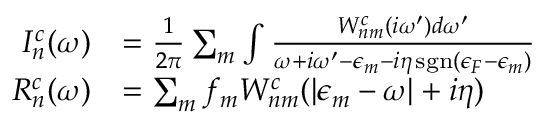<formula> <loc_0><loc_0><loc_500><loc_500>\begin{array} { r l } { I _ { n } ^ { c } ( \omega ) } & { = \frac { 1 } { 2 \pi } \sum _ { m } \int \frac { W _ { n m } ^ { c } ( i \omega ^ { \prime } ) d \omega ^ { \prime } } { \omega + i \omega ^ { \prime } - \epsilon _ { m } - i \eta \, s g n ( \epsilon _ { F } - \epsilon _ { m } ) } } \\ { R _ { n } ^ { c } ( \omega ) } & { = \sum _ { m } f _ { m } W _ { n m } ^ { c } ( | \epsilon _ { m } - \omega | + i \eta ) } \end{array}</formula> 